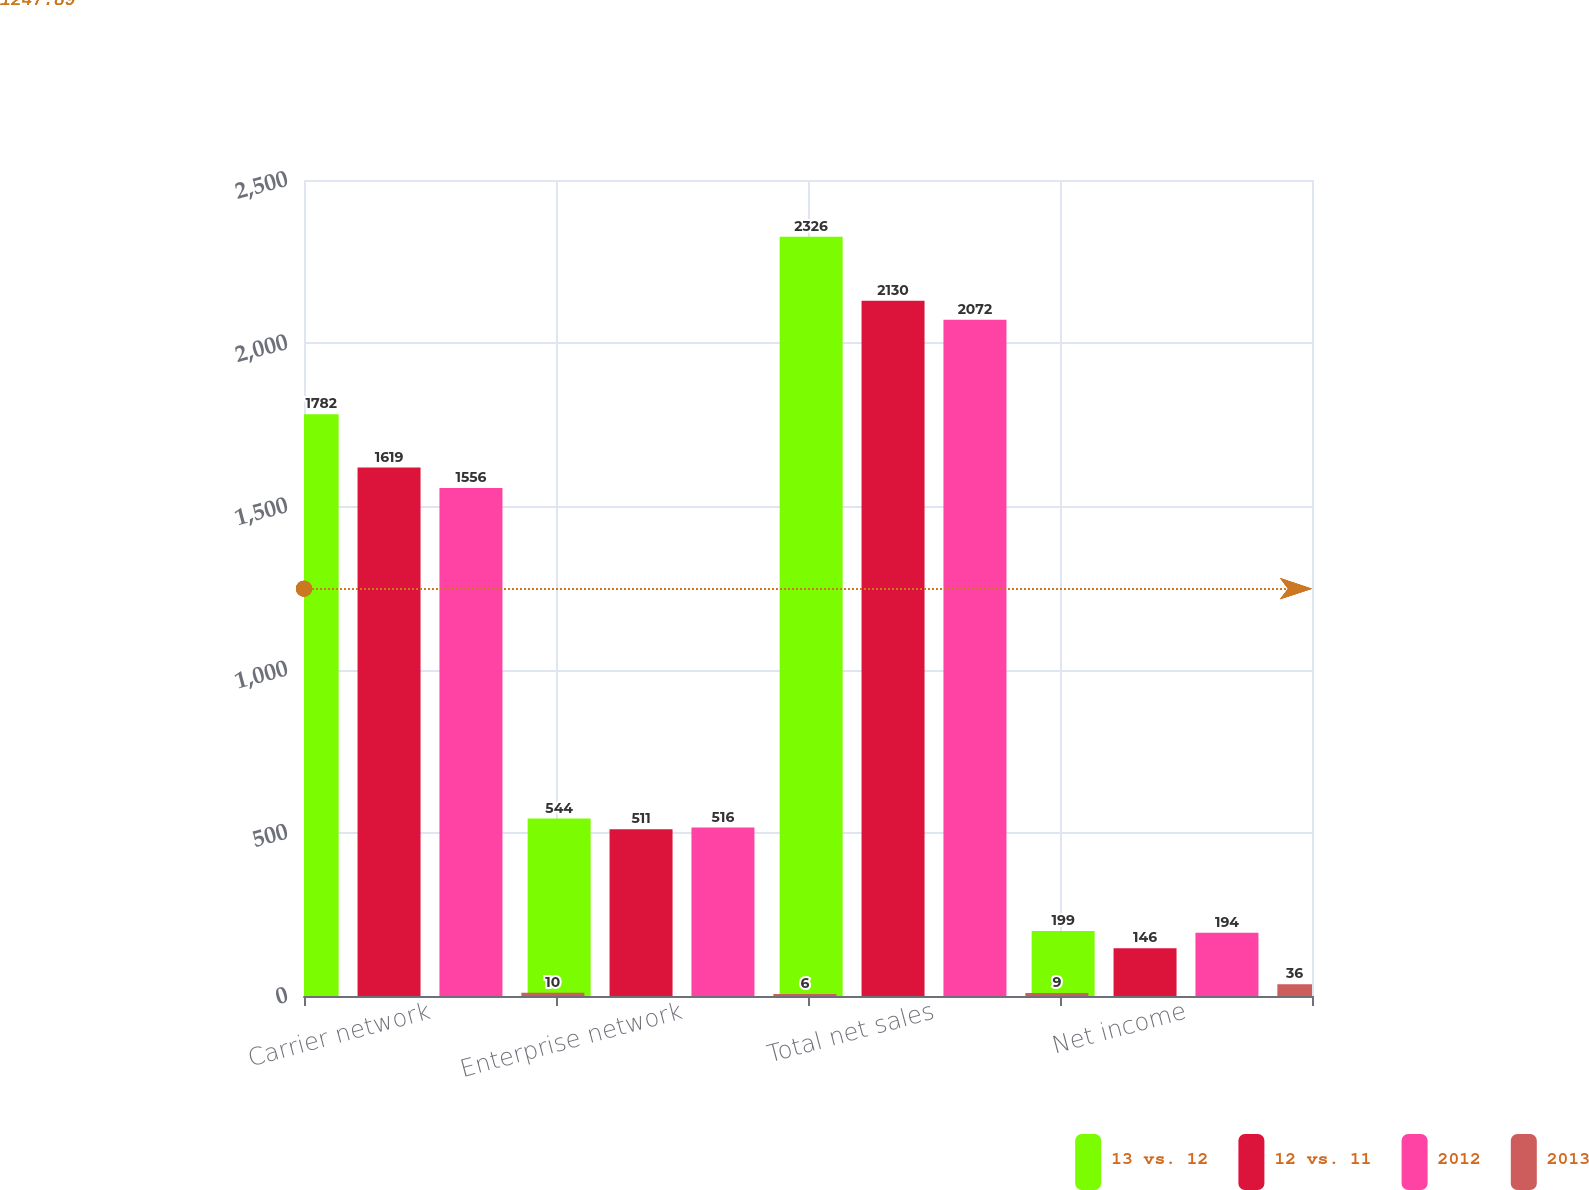Convert chart. <chart><loc_0><loc_0><loc_500><loc_500><stacked_bar_chart><ecel><fcel>Carrier network<fcel>Enterprise network<fcel>Total net sales<fcel>Net income<nl><fcel>13 vs. 12<fcel>1782<fcel>544<fcel>2326<fcel>199<nl><fcel>12 vs. 11<fcel>1619<fcel>511<fcel>2130<fcel>146<nl><fcel>2012<fcel>1556<fcel>516<fcel>2072<fcel>194<nl><fcel>2013<fcel>10<fcel>6<fcel>9<fcel>36<nl></chart> 